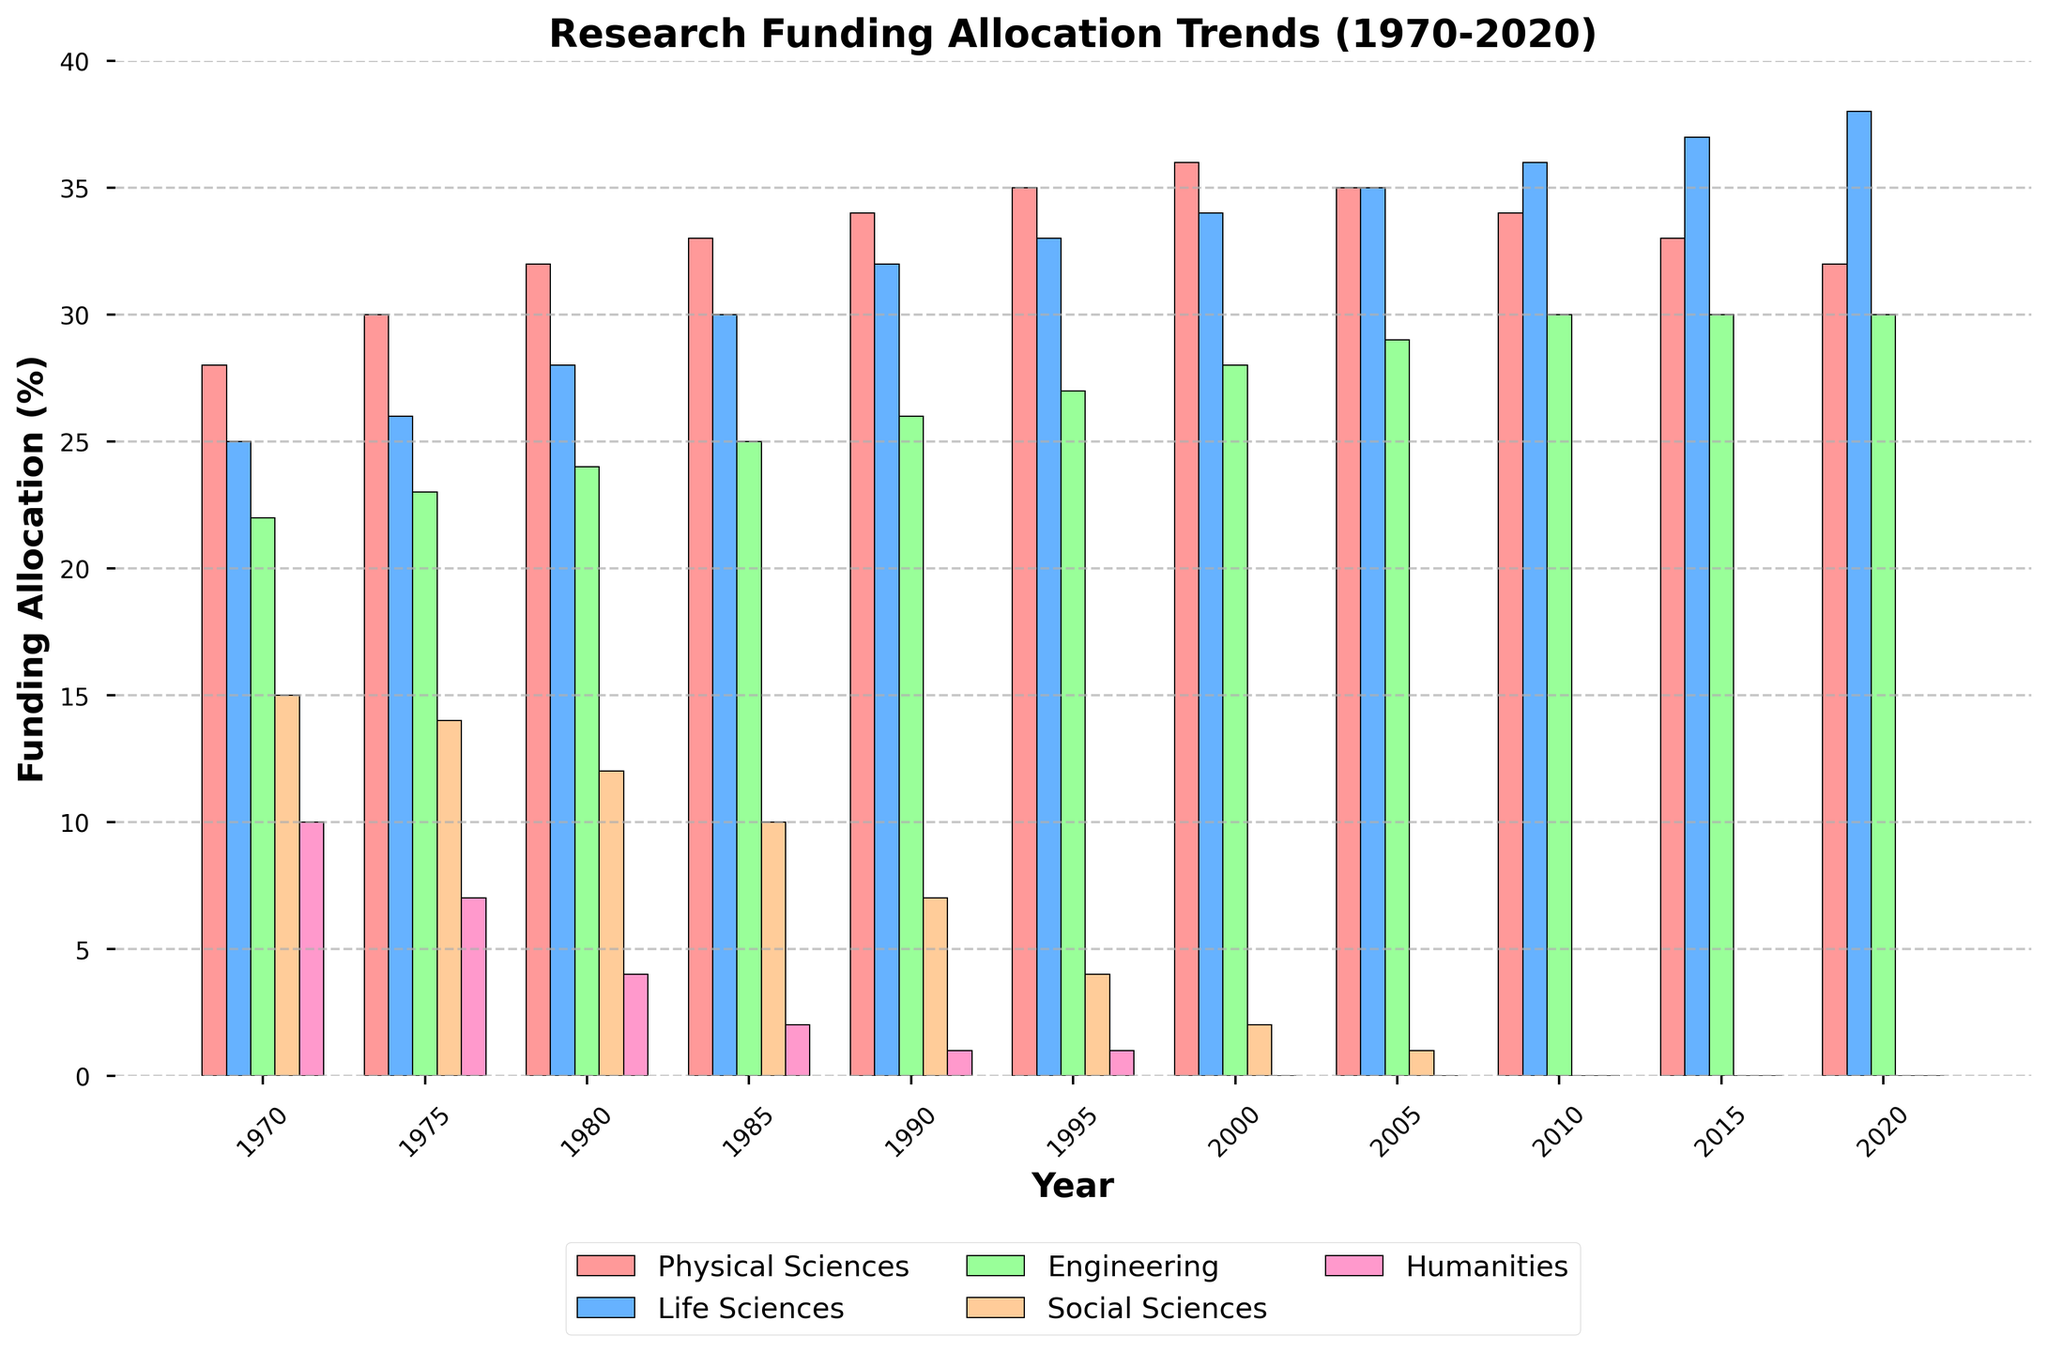Which field had the highest funding allocation in 2020? Look at the bars representing 2020 and find the tallest one. The tallest bar represents Life Sciences.
Answer: Life Sciences How did the funding for Social Sciences change between 1970 and 2020? Identify the height of the bars for Social Sciences in 1970 and 2020. In 1970, the bar is at 15%, while in 2020, it is at 0%. Subtract to find the difference: 15% - 0% = 15%.
Answer: Decreased by 15% What is the total funding allocation percentage for the Physical Sciences and Life Sciences in 2000? Look at the bars for Physical Sciences and Life Sciences in the year 2000. Physical Sciences is at 36%, and Life Sciences is at 34%. Add them together: 36% + 34% = 70%.
Answer: 70% Between which two consecutive years did the Humanities field first reach 0% funding? Look for the year where the Humanities field first reaches 0%. The bar for Humanities is at 0% starting from 2000. Therefore, the change happened between 1995 and 2000.
Answer: 1995 and 2000 Which field consistently declined in funding allocation from 1970 to 2020? Analyze the trend lines for each field from 1970 to 2020. The Social Sciences and Humanities fields show consistent decline, but Humanities reaches 0% funding completely, making it the consistent decliner.
Answer: Humanities What is the percentage difference in funding between Physical Sciences and Engineering in 1990? Look at the bars for Physical Sciences and Engineering in 1990. Physical Sciences is at 34%, and Engineering is at 26%. Subtract to find the difference: 34% - 26% = 8%.
Answer: 8% In which year did Engineering receive 29% of the funding? Find the year where the Engineering field's bar reaches 29%. It reaches 29% in the year 2005.
Answer: 2005 What trend do you observe in the Life Sciences funding allocation from 1970 to 2020? Look at the bars representing Life Sciences across different years. The height of these bars increases consistently from 25% in 1970 to 38% in 2020.
Answer: Increasing trend When did Life Sciences funding first surpass Physical Sciences? Compare the heights of bars for Life Sciences and Physical Sciences until Life Sciences exceeds Physical Sciences. This first happens in the year 2005 where both are equal, but Life Sciences continues to grow afterward.
Answer: 2005 What is the sum of the funding allocation percentages for all fields in 1985? Add the heights of bars for all fields in the year 1985. 33% (Physical Sciences) + 30% (Life Sciences) + 25% (Engineering) + 10% (Social Sciences) + 2% (Humanities) = 100%.
Answer: 100% 